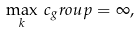Convert formula to latex. <formula><loc_0><loc_0><loc_500><loc_500>\max _ { k } \, c _ { g } r o u p = \infty ,</formula> 